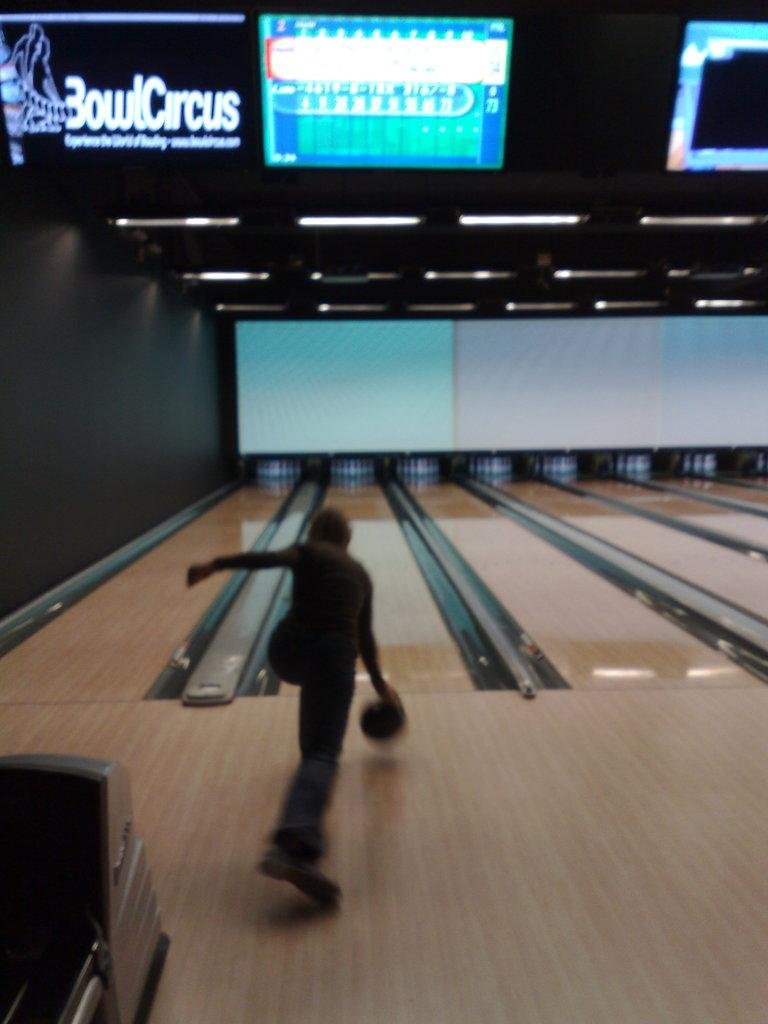What activity is the person in the image engaged in? The person in the image is playing bowling. What objects are involved in the game of bowling? There are bowling pins in the image. What can be seen illuminating the area in the image? There are lights in the image. What type of signage is present in the image? There are boards with text in the image. What is used to hold the bowling ball in the image? There is a ball stand in the image. What type of flooring is visible in the image? There is a wooden floor in the image. What type of chin is visible on the bushes in the image? There are no bushes or chins present in the image; it features a person playing bowling with related equipment and surroundings. 